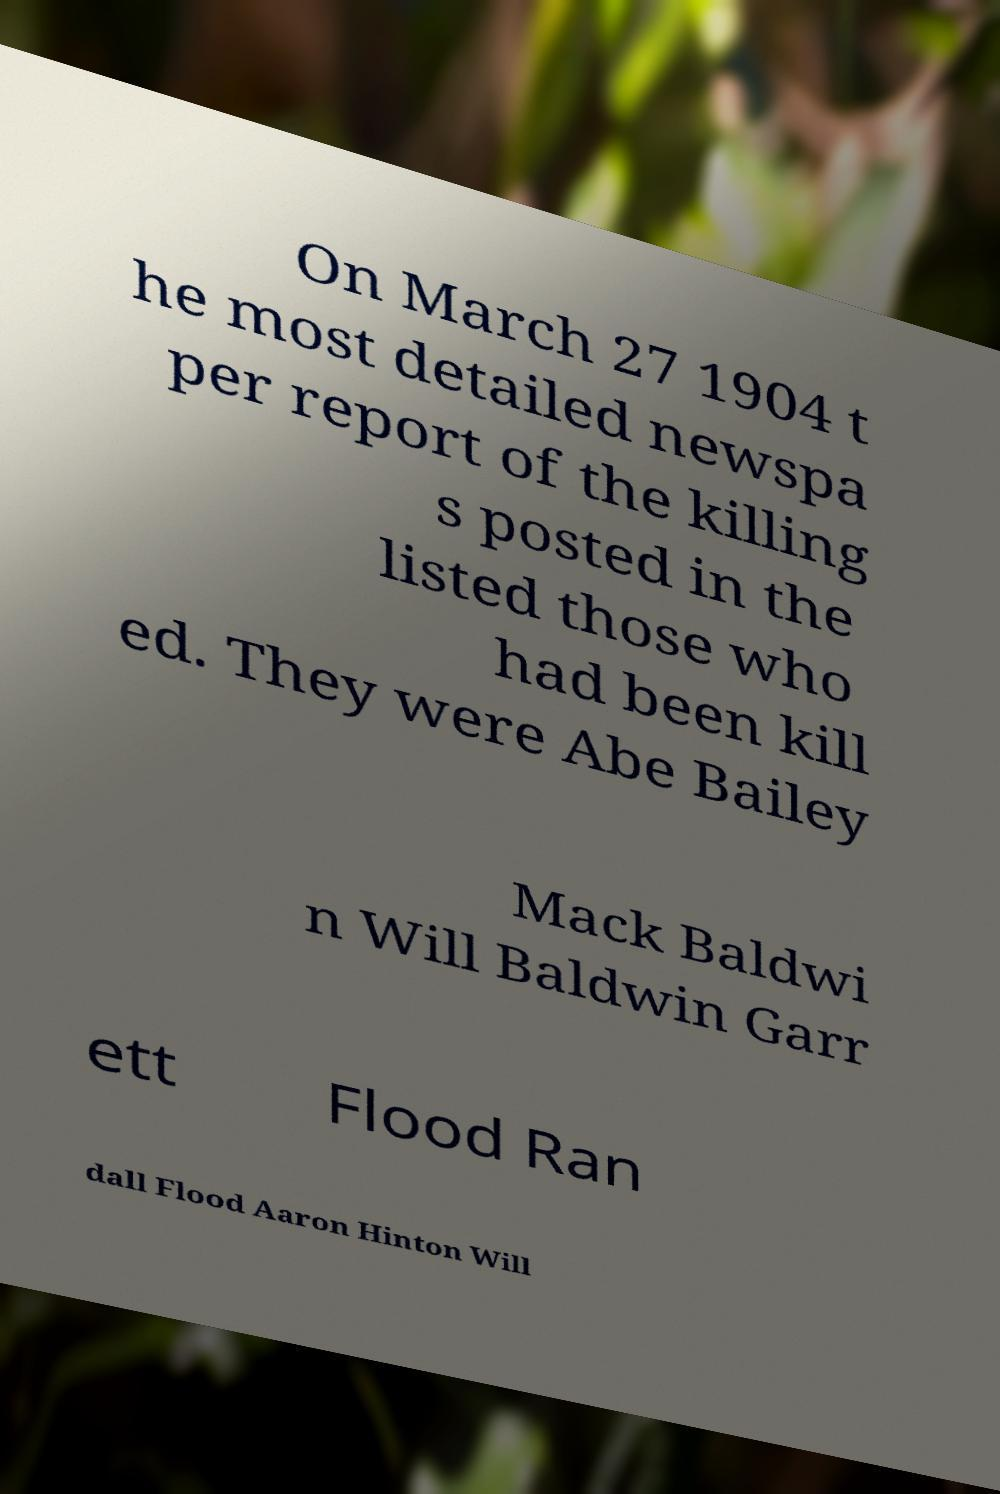Can you read and provide the text displayed in the image?This photo seems to have some interesting text. Can you extract and type it out for me? On March 27 1904 t he most detailed newspa per report of the killing s posted in the listed those who had been kill ed. They were Abe Bailey Mack Baldwi n Will Baldwin Garr ett Flood Ran dall Flood Aaron Hinton Will 